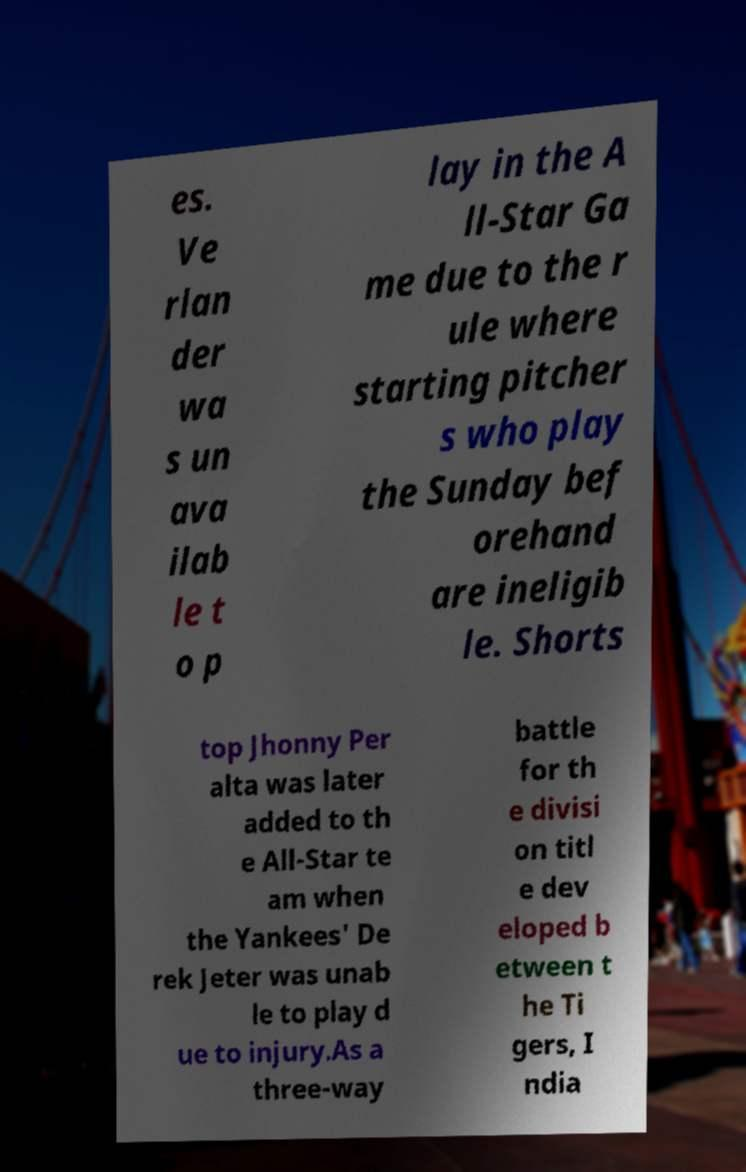Could you extract and type out the text from this image? es. Ve rlan der wa s un ava ilab le t o p lay in the A ll-Star Ga me due to the r ule where starting pitcher s who play the Sunday bef orehand are ineligib le. Shorts top Jhonny Per alta was later added to th e All-Star te am when the Yankees' De rek Jeter was unab le to play d ue to injury.As a three-way battle for th e divisi on titl e dev eloped b etween t he Ti gers, I ndia 